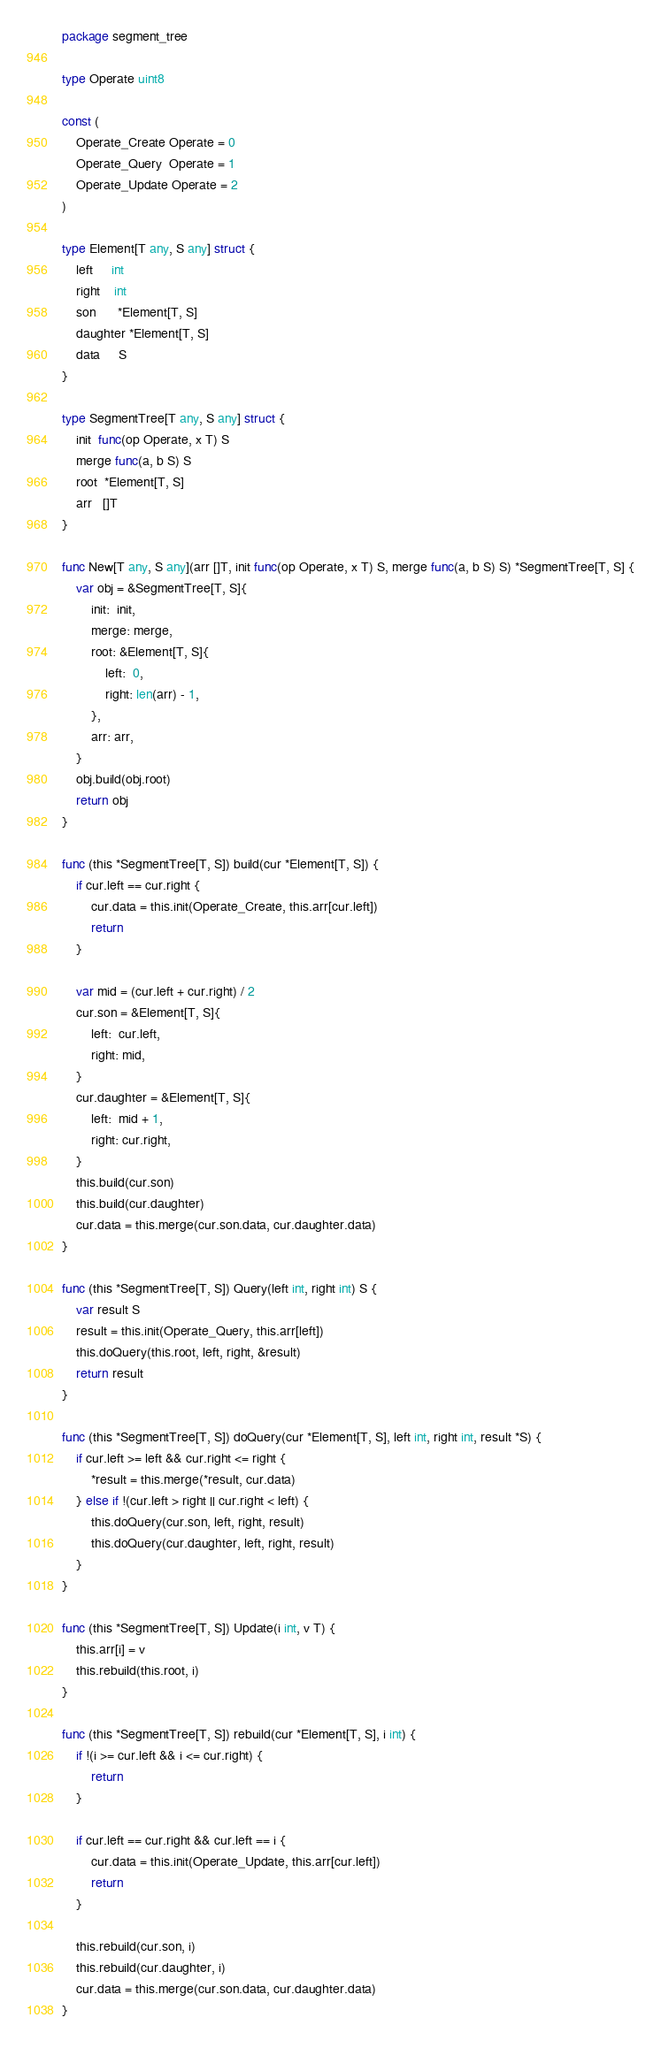Convert code to text. <code><loc_0><loc_0><loc_500><loc_500><_Go_>package segment_tree

type Operate uint8

const (
	Operate_Create Operate = 0
	Operate_Query  Operate = 1
	Operate_Update Operate = 2
)

type Element[T any, S any] struct {
	left     int
	right    int
	son      *Element[T, S]
	daughter *Element[T, S]
	data     S
}

type SegmentTree[T any, S any] struct {
	init  func(op Operate, x T) S
	merge func(a, b S) S
	root  *Element[T, S]
	arr   []T
}

func New[T any, S any](arr []T, init func(op Operate, x T) S, merge func(a, b S) S) *SegmentTree[T, S] {
	var obj = &SegmentTree[T, S]{
		init:  init,
		merge: merge,
		root: &Element[T, S]{
			left:  0,
			right: len(arr) - 1,
		},
		arr: arr,
	}
	obj.build(obj.root)
	return obj
}

func (this *SegmentTree[T, S]) build(cur *Element[T, S]) {
	if cur.left == cur.right {
		cur.data = this.init(Operate_Create, this.arr[cur.left])
		return
	}

	var mid = (cur.left + cur.right) / 2
	cur.son = &Element[T, S]{
		left:  cur.left,
		right: mid,
	}
	cur.daughter = &Element[T, S]{
		left:  mid + 1,
		right: cur.right,
	}
	this.build(cur.son)
	this.build(cur.daughter)
	cur.data = this.merge(cur.son.data, cur.daughter.data)
}

func (this *SegmentTree[T, S]) Query(left int, right int) S {
	var result S
	result = this.init(Operate_Query, this.arr[left])
	this.doQuery(this.root, left, right, &result)
	return result
}

func (this *SegmentTree[T, S]) doQuery(cur *Element[T, S], left int, right int, result *S) {
	if cur.left >= left && cur.right <= right {
		*result = this.merge(*result, cur.data)
	} else if !(cur.left > right || cur.right < left) {
		this.doQuery(cur.son, left, right, result)
		this.doQuery(cur.daughter, left, right, result)
	}
}

func (this *SegmentTree[T, S]) Update(i int, v T) {
	this.arr[i] = v
	this.rebuild(this.root, i)
}

func (this *SegmentTree[T, S]) rebuild(cur *Element[T, S], i int) {
	if !(i >= cur.left && i <= cur.right) {
		return
	}

	if cur.left == cur.right && cur.left == i {
		cur.data = this.init(Operate_Update, this.arr[cur.left])
		return
	}

	this.rebuild(cur.son, i)
	this.rebuild(cur.daughter, i)
	cur.data = this.merge(cur.son.data, cur.daughter.data)
}
</code> 